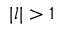<formula> <loc_0><loc_0><loc_500><loc_500>| l | > 1</formula> 